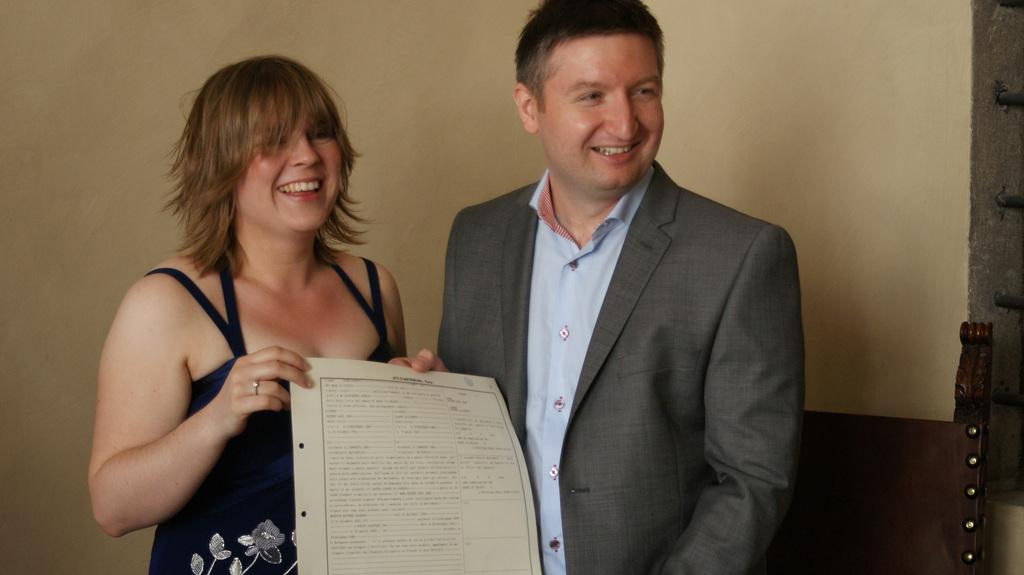Who is present in the image? There is a woman and a man in the image. What are the woman and the man doing in the image? The woman and the man are holding a paper with their hands and smiling. What can be seen in the background of the image? There is a wooden object and a wall visible in the background. Can you see any fog in the image? There is no fog visible in the image. What type of pump is being used by the woman in the image? There is no pump present in the image. 